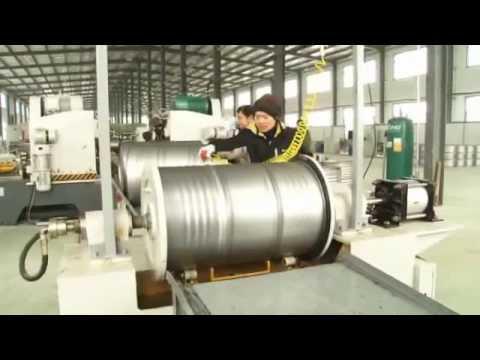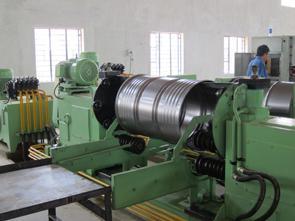The first image is the image on the left, the second image is the image on the right. Assess this claim about the two images: "An image shows silver barrels on their sides flanked by greenish-bluish painted equipment, and a man in a blue shirt on the far right.". Correct or not? Answer yes or no. Yes. The first image is the image on the left, the second image is the image on the right. Given the left and right images, does the statement "People work near silver barrels in at least one of the images." hold true? Answer yes or no. Yes. 